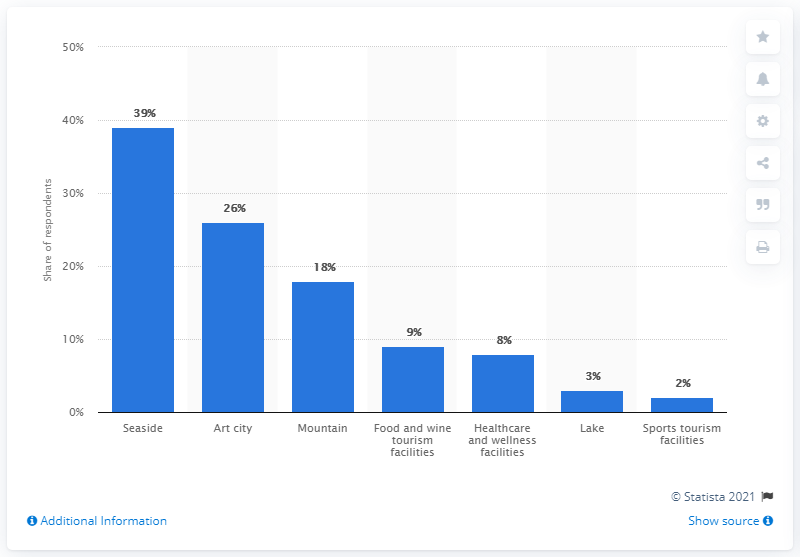Highlight a few significant elements in this photo. According to a survey, 39% of Italians expressed a willingness to visit national seaside tourist locations. 